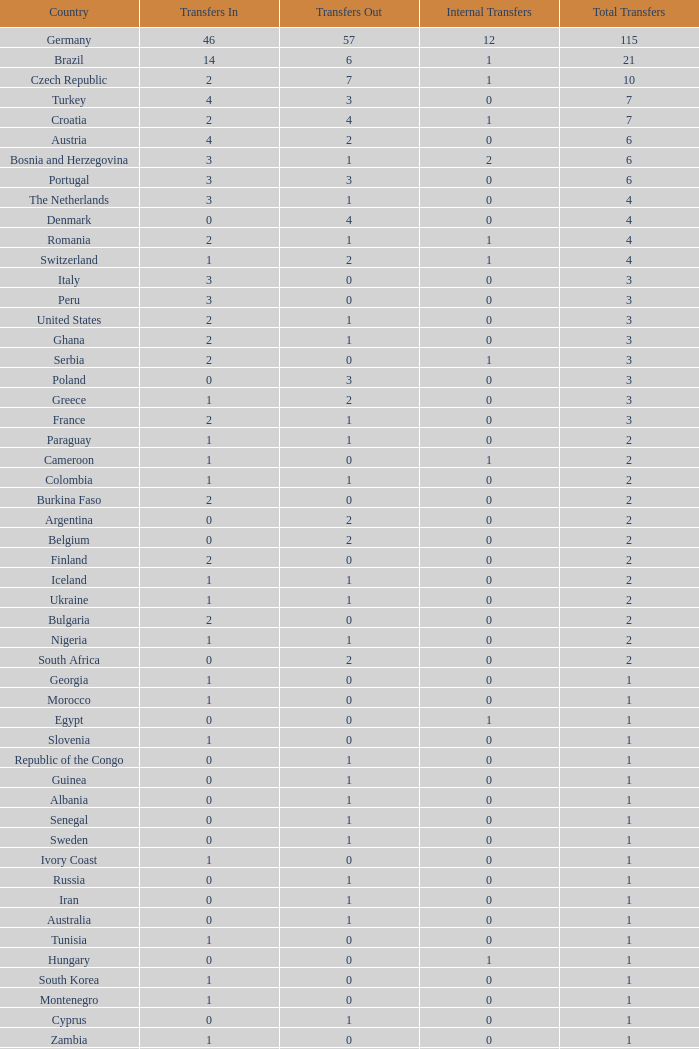What are the transfers in for Hungary? 0.0. 